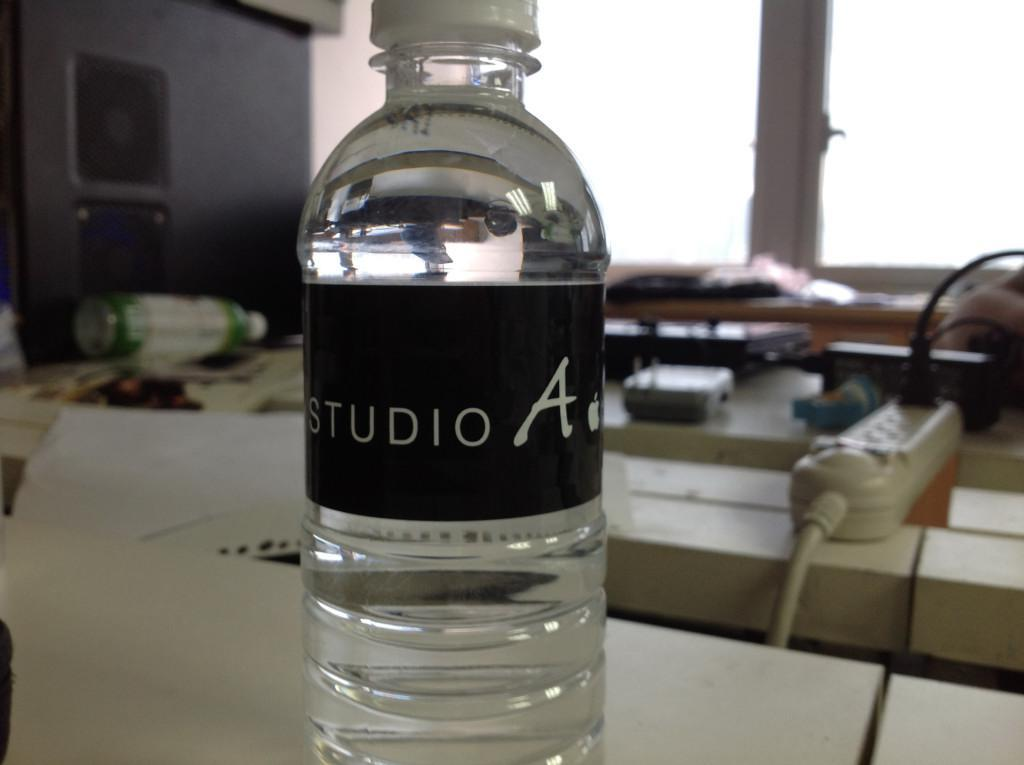<image>
Provide a brief description of the given image. A clear watter bottle with a black logo that reads studio A on it. 